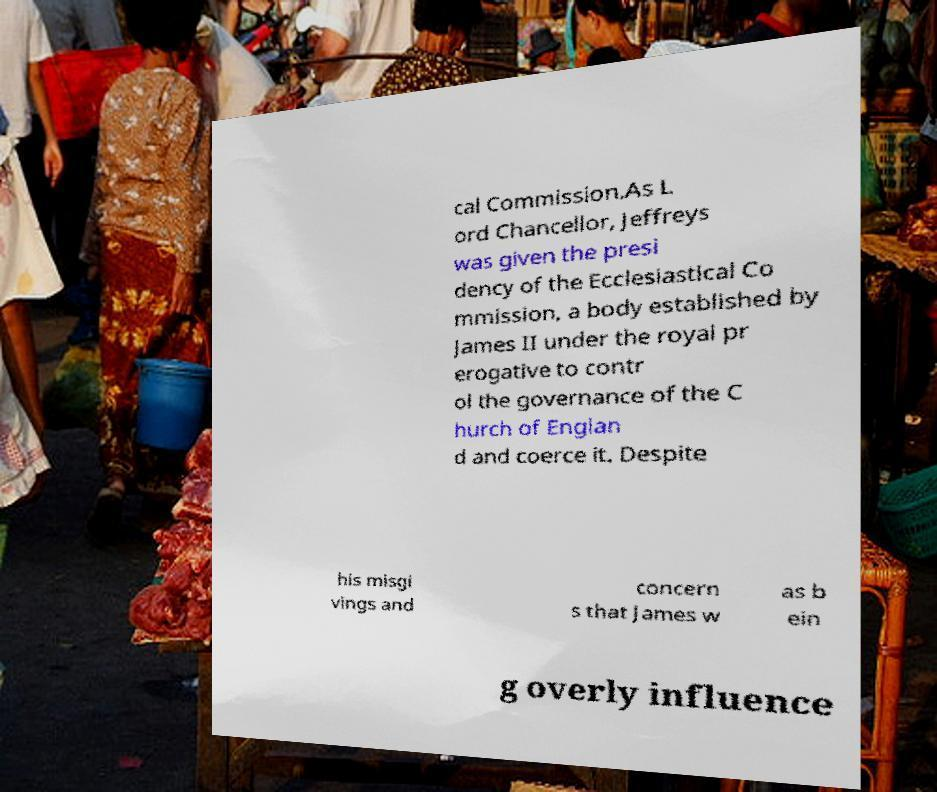What messages or text are displayed in this image? I need them in a readable, typed format. cal Commission.As L ord Chancellor, Jeffreys was given the presi dency of the Ecclesiastical Co mmission, a body established by James II under the royal pr erogative to contr ol the governance of the C hurch of Englan d and coerce it. Despite his misgi vings and concern s that James w as b ein g overly influence 